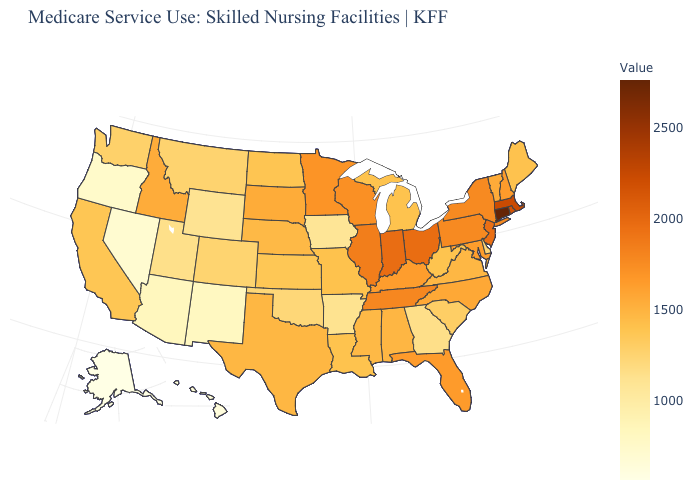Does Alaska have the lowest value in the USA?
Answer briefly. Yes. Which states have the lowest value in the West?
Concise answer only. Alaska. Does Arkansas have the lowest value in the South?
Answer briefly. Yes. Among the states that border Wyoming , which have the highest value?
Quick response, please. South Dakota. Does Iowa have the lowest value in the MidWest?
Be succinct. Yes. Which states hav the highest value in the MidWest?
Keep it brief. Ohio. Which states have the lowest value in the West?
Write a very short answer. Alaska. Does New Hampshire have a higher value than Indiana?
Concise answer only. No. Does Indiana have the lowest value in the MidWest?
Give a very brief answer. No. Which states have the lowest value in the West?
Quick response, please. Alaska. 